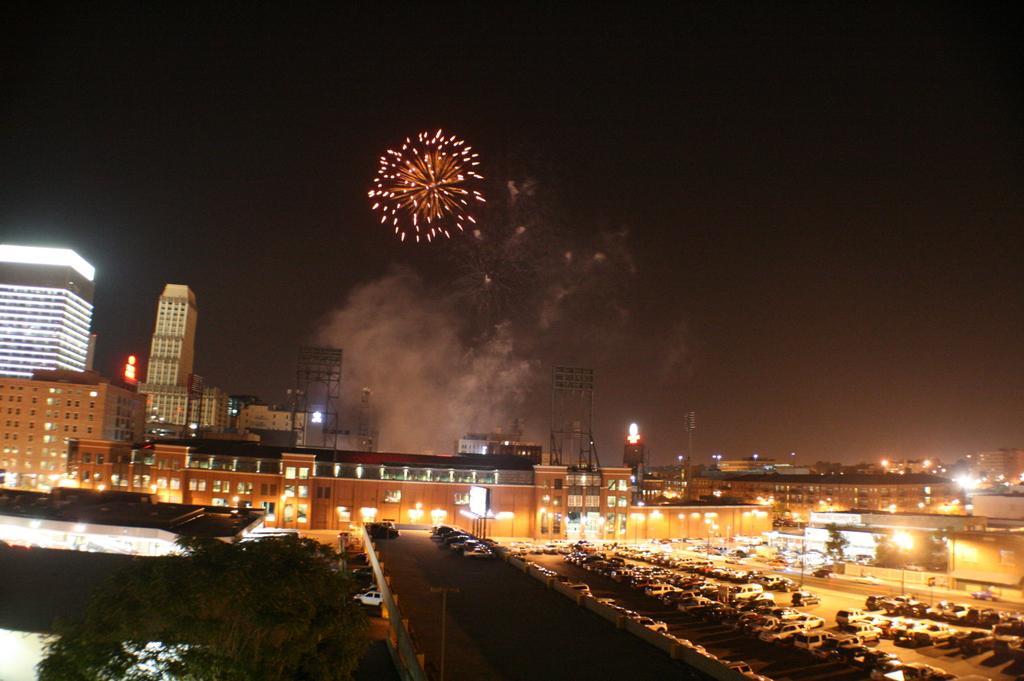In one or two sentences, can you explain what this image depicts? This image in the center there are cars on the road. On the left side there is a tree and in the background there are buildings, there is smoke and there is a sparkle in the sky. 